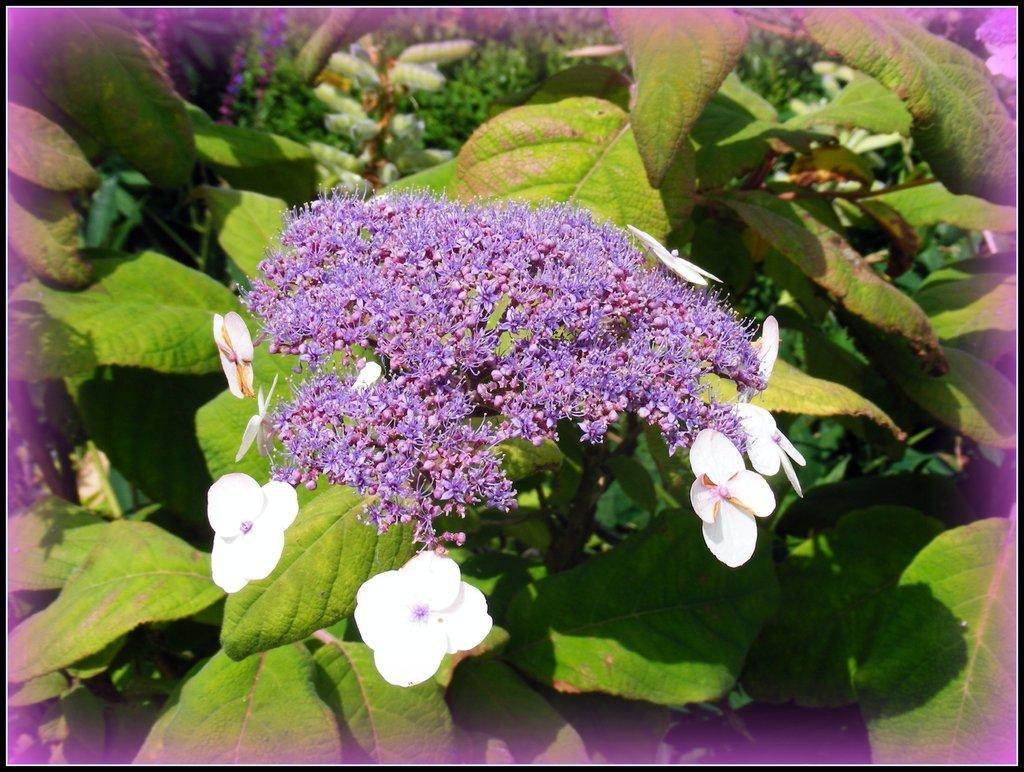What type of plants are visible in the image? There is a group of flowers in the image. What else can be seen in the image besides the flowers? There are leaves in the image. What type of teeth can be seen in the image? There are no teeth visible in the image, as it features a group of flowers and leaves. 